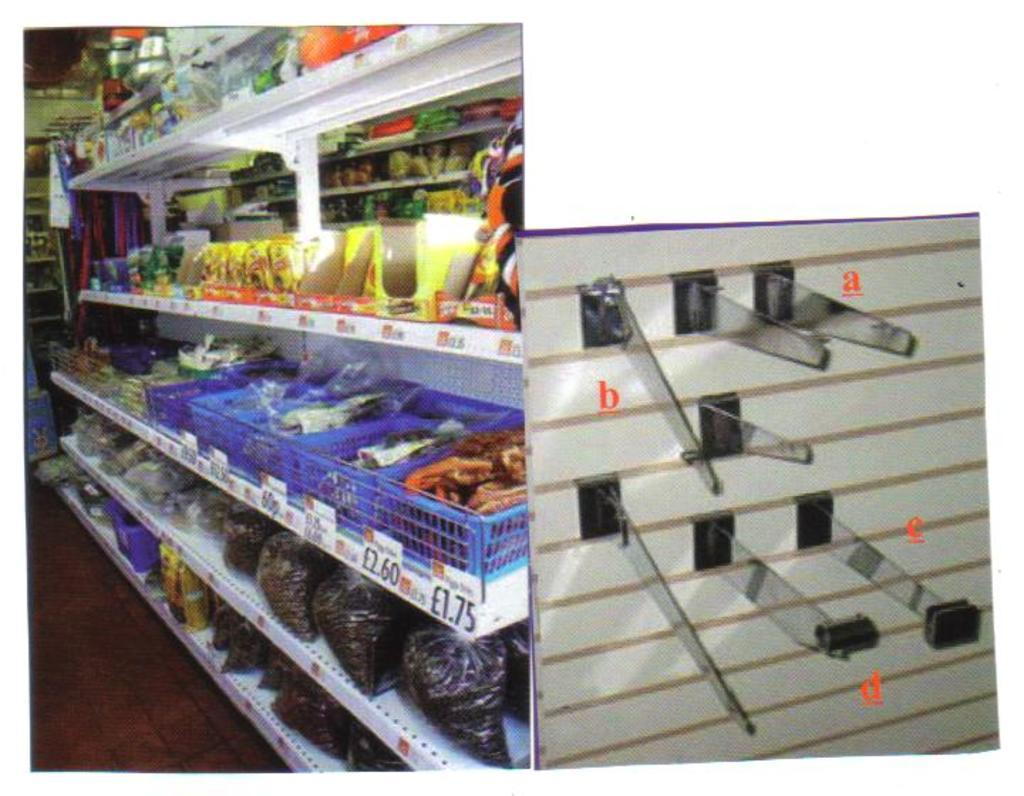<image>
Summarize the visual content of the image. A basket of snacks can be purchased for 1.75 euros a piece 